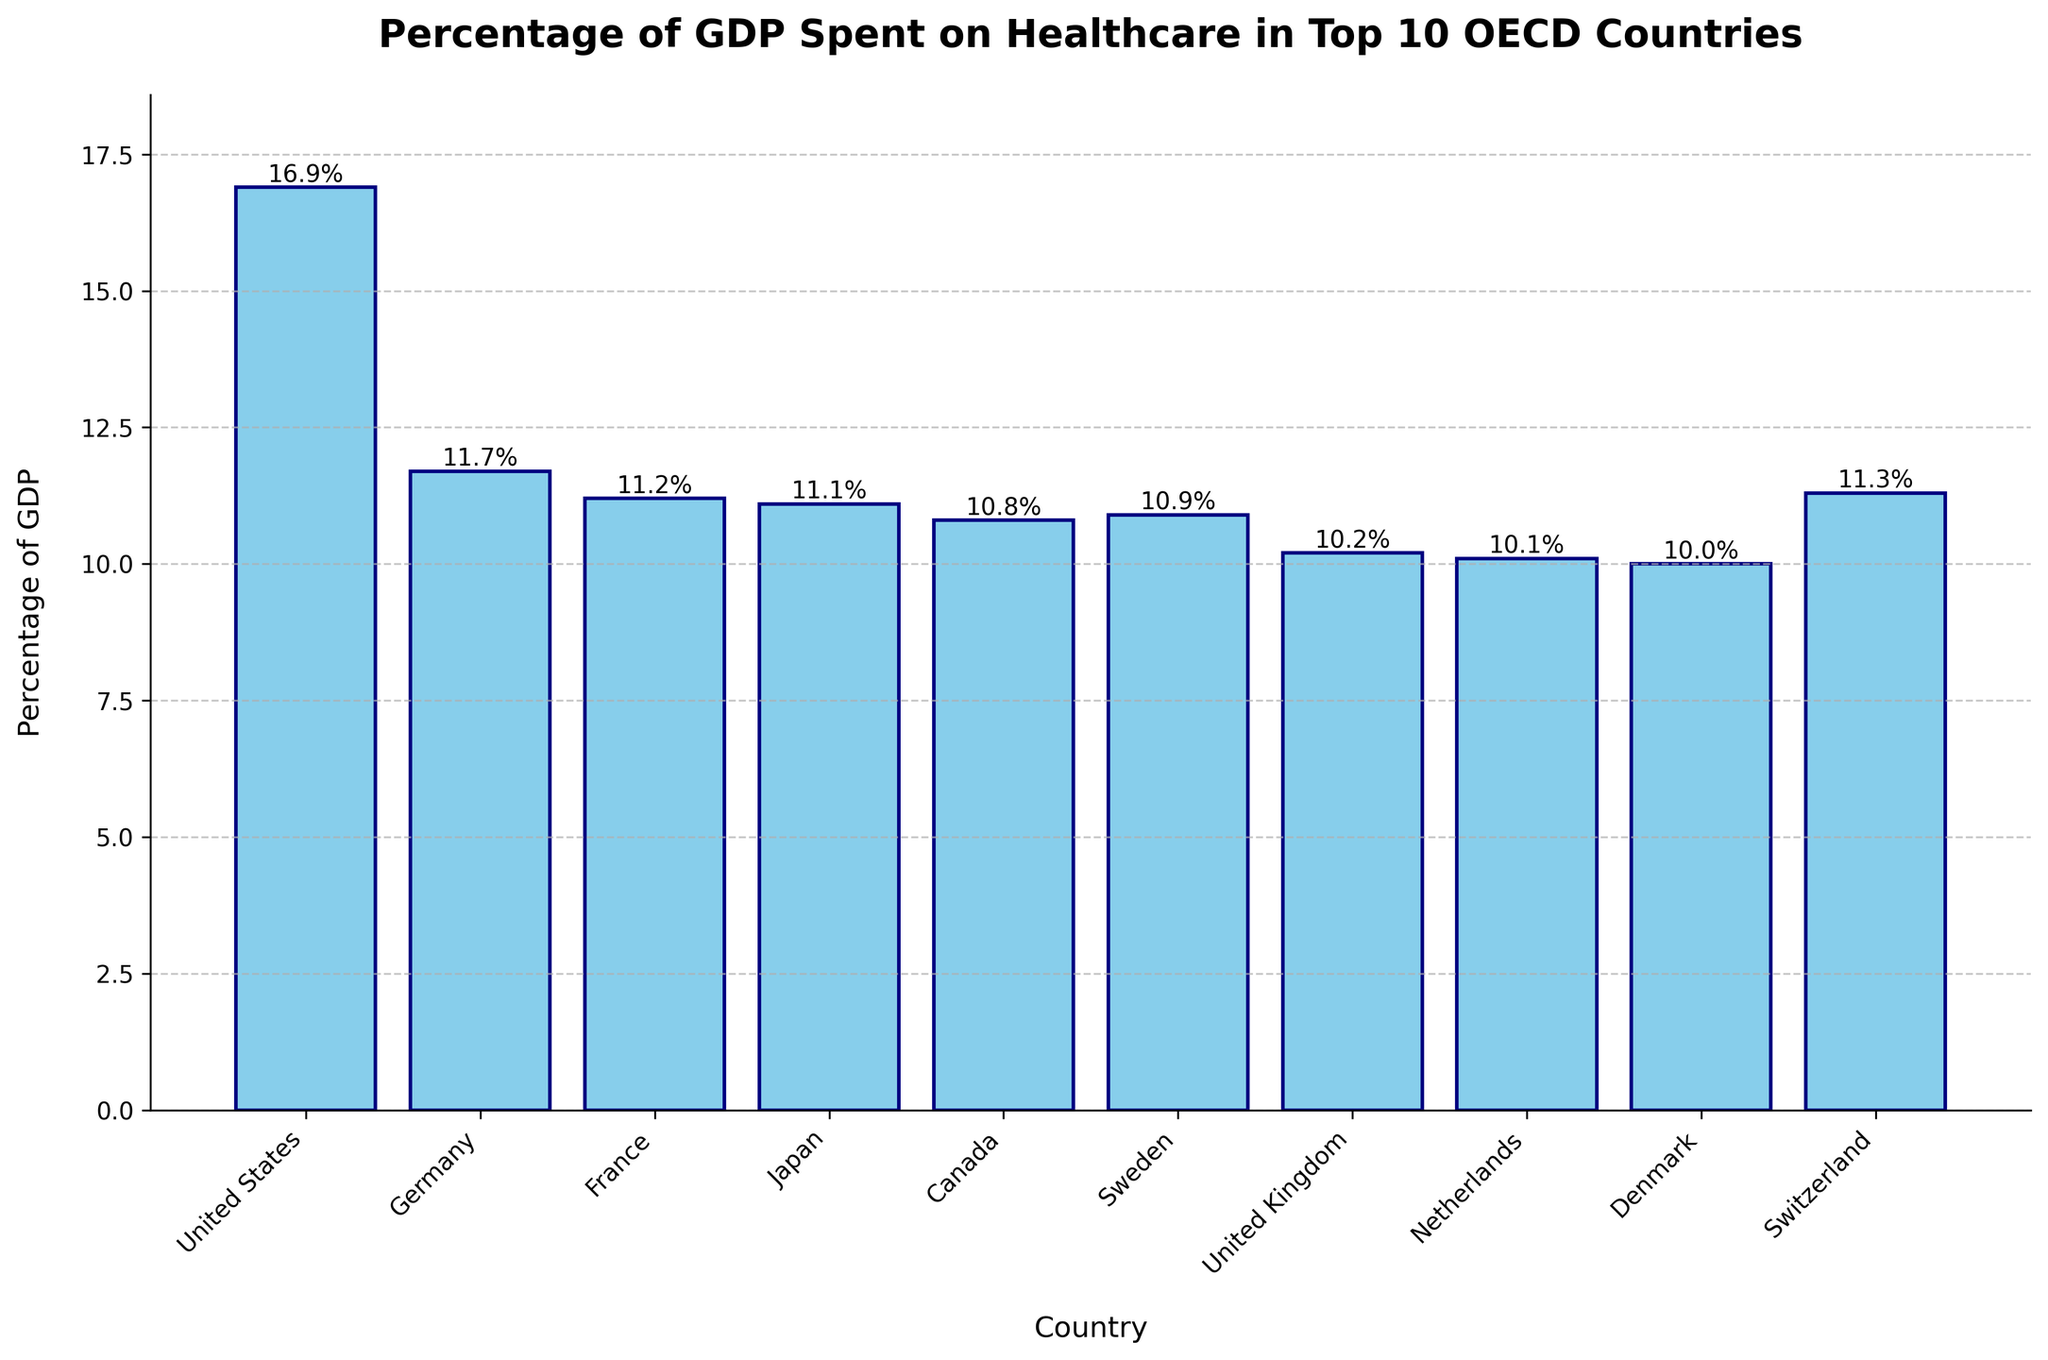What country spends the highest percentage of GDP on healthcare? The highest bar represents the country that spends the most. The United States bar is the tallest at 16.9%.
Answer: United States Which countries spend more than 11% of their GDP on healthcare? Identify the bars that reach above the 11% mark. These countries are the United States (16.9%), Germany (11.7%), France (11.2%), Japan (11.1%), and Switzerland (11.3%).
Answer: United States, Germany, France, Japan, Switzerland How much more does the United States spend on healthcare compared to Canada as a percentage of GDP? Subtract Canada's percentage (10.8%) from the United States' percentage (16.9%). The difference is 16.9 - 10.8 = 6.1.
Answer: 6.1% What is the average percentage of GDP spent on healthcare among these top 10 OECD countries? Sum all percentages and divide by the number of countries (10). (16.9 + 11.7 + 11.2 + 11.1 + 10.8 + 10.9 + 10.2 + 10.1 + 10.0 + 11.3) / 10 = 114.2 / 10 = 11.42.
Answer: 11.42% Which countries have an approximately equal percentage of GDP spent on healthcare? Look for bars of similar height. Japan (11.1%) and France (11.2%) are nearly equal, and Canada (10.8%) and Sweden (10.9%) are also close.
Answer: Japan and France; Canada and Sweden Rank the countries by the percentage of GDP spent on healthcare from highest to lowest. List the countries in descending order based on the height of the bars. The order is United States, Germany, Switzerland, France, Japan, Sweden, Canada, United Kingdom, Netherlands, Denmark.
Answer: United States, Germany, Switzerland, France, Japan, Sweden, Canada, United Kingdom, Netherlands, Denmark Which country spends the least percentage of their GDP on healthcare? The shortest bar represents the country that spends the least. Denmark has the shortest bar at 10.0%.
Answer: Denmark What's the difference in GDP spent on healthcare between Germany and the United Kingdom? Subtract the United Kingdom’s percentage (10.2%) from Germany’s percentage (11.7%). The difference is 11.7 - 10.2 = 1.5.
Answer: 1.5% Are there any countries with exactly a 10% GDP expenditure on healthcare? Find the bar that aligns exactly with the 10% mark. Denmark is at 10.0%.
Answer: Denmark What is the median percentage of GDP spent on healthcare in these countries? Arrange the GDP percentages in ascending order and find the middle value. The percentages are 10.0, 10.1, 10.2, 10.8, 10.9, 11.1, 11.2, 11.3, 11.7, 16.9. The median values are the average of the 5th and 6th values: (10.9 + 11.1) / 2 = 11.0.
Answer: 11.0% 